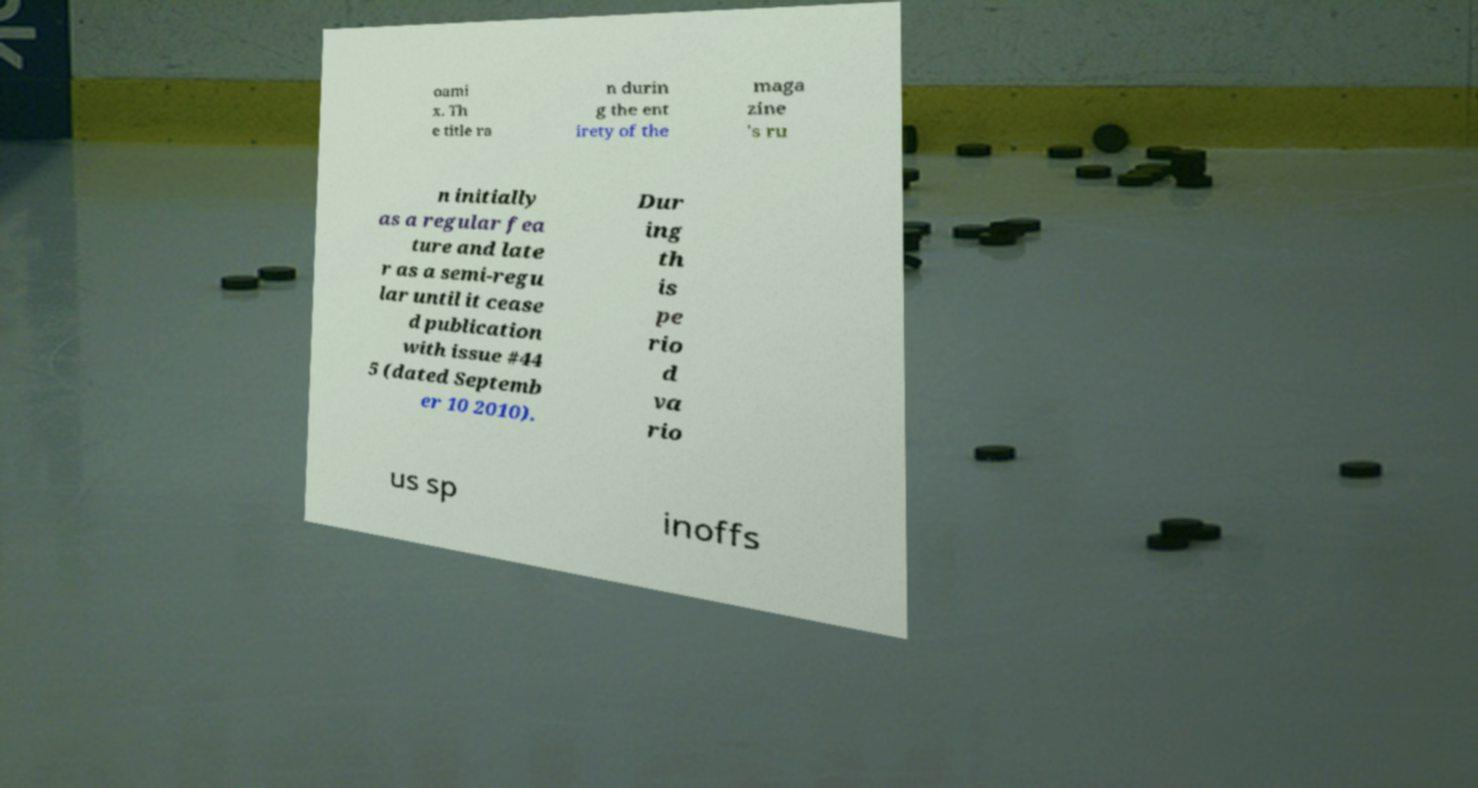I need the written content from this picture converted into text. Can you do that? oami x. Th e title ra n durin g the ent irety of the maga zine 's ru n initially as a regular fea ture and late r as a semi-regu lar until it cease d publication with issue #44 5 (dated Septemb er 10 2010). Dur ing th is pe rio d va rio us sp inoffs 